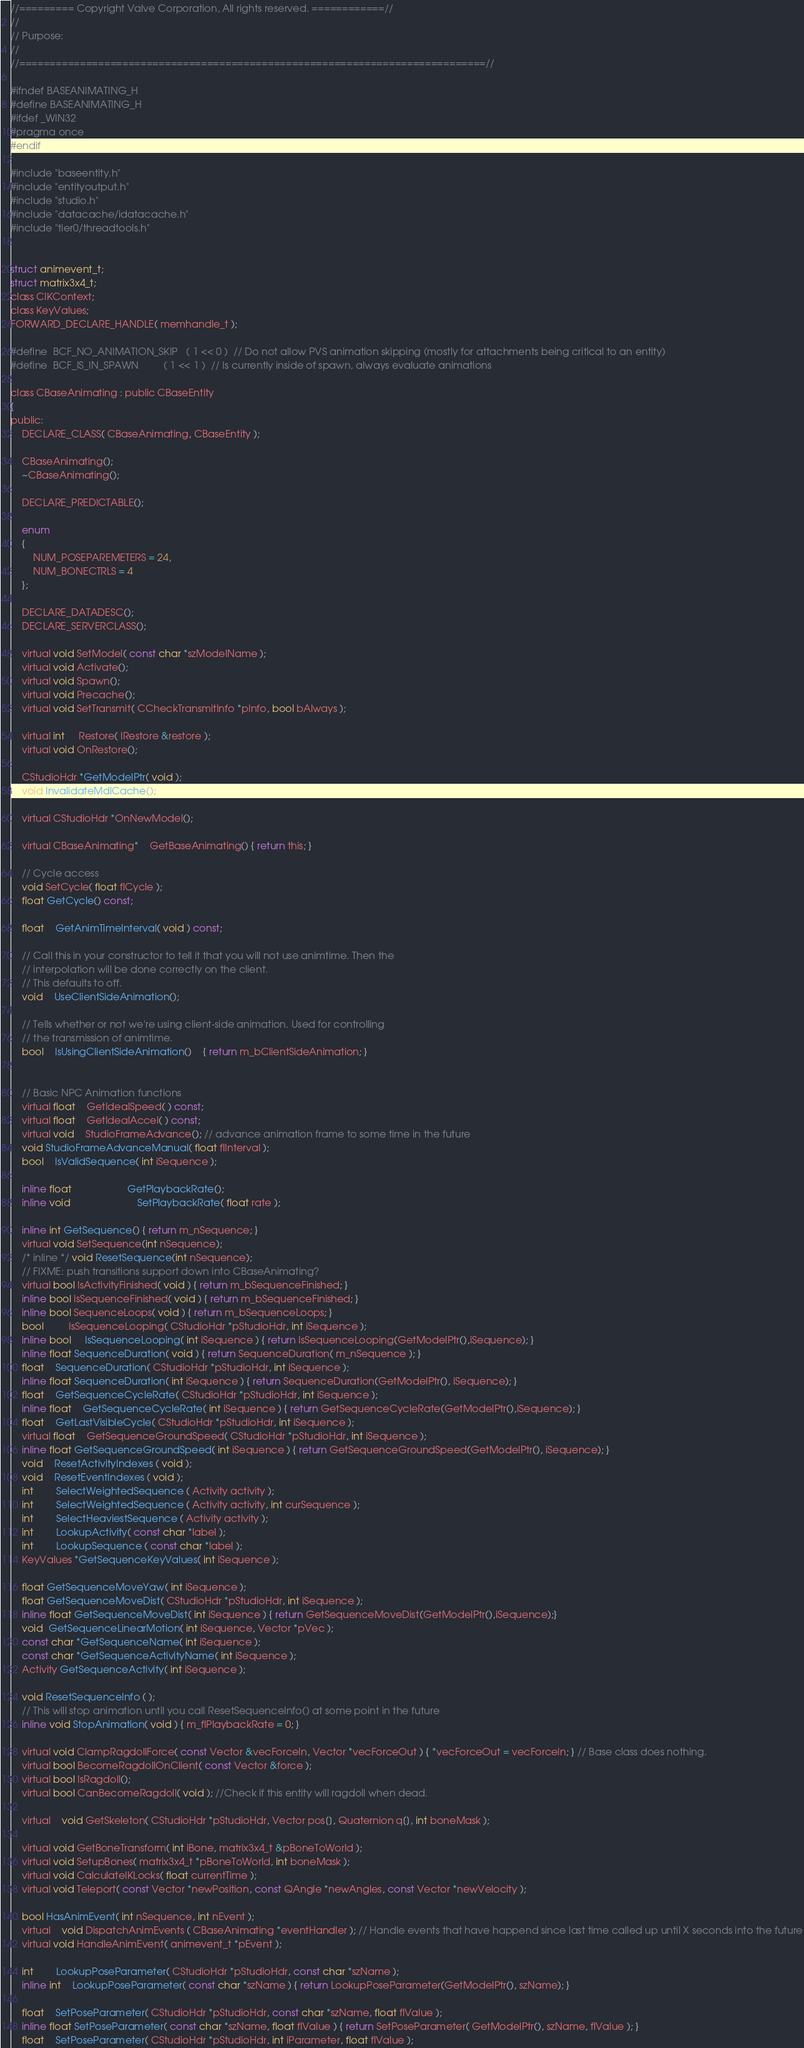<code> <loc_0><loc_0><loc_500><loc_500><_C_>//========= Copyright Valve Corporation, All rights reserved. ============//
//
// Purpose: 
//
//=============================================================================//

#ifndef BASEANIMATING_H
#define BASEANIMATING_H
#ifdef _WIN32
#pragma once
#endif

#include "baseentity.h"
#include "entityoutput.h"
#include "studio.h"
#include "datacache/idatacache.h"
#include "tier0/threadtools.h"


struct animevent_t;
struct matrix3x4_t;
class CIKContext;
class KeyValues;
FORWARD_DECLARE_HANDLE( memhandle_t );

#define	BCF_NO_ANIMATION_SKIP	( 1 << 0 )	// Do not allow PVS animation skipping (mostly for attachments being critical to an entity)
#define	BCF_IS_IN_SPAWN			( 1 << 1 )	// Is currently inside of spawn, always evaluate animations

class CBaseAnimating : public CBaseEntity
{
public:
	DECLARE_CLASS( CBaseAnimating, CBaseEntity );

	CBaseAnimating();
	~CBaseAnimating();

	DECLARE_PREDICTABLE();

	enum
	{
		NUM_POSEPAREMETERS = 24,
		NUM_BONECTRLS = 4
	};

	DECLARE_DATADESC();
	DECLARE_SERVERCLASS();

	virtual void SetModel( const char *szModelName );
	virtual void Activate();
	virtual void Spawn();
	virtual void Precache();
	virtual void SetTransmit( CCheckTransmitInfo *pInfo, bool bAlways );

	virtual int	 Restore( IRestore &restore );
	virtual void OnRestore();

	CStudioHdr *GetModelPtr( void );
	void InvalidateMdlCache();

	virtual CStudioHdr *OnNewModel();

	virtual CBaseAnimating*	GetBaseAnimating() { return this; }

	// Cycle access
	void SetCycle( float flCycle );
	float GetCycle() const;

	float	GetAnimTimeInterval( void ) const;

	// Call this in your constructor to tell it that you will not use animtime. Then the
	// interpolation will be done correctly on the client.
	// This defaults to off.
	void	UseClientSideAnimation();

	// Tells whether or not we're using client-side animation. Used for controlling
	// the transmission of animtime.
	bool	IsUsingClientSideAnimation()	{ return m_bClientSideAnimation; }


	// Basic NPC Animation functions
	virtual float	GetIdealSpeed( ) const;
	virtual float	GetIdealAccel( ) const;
	virtual void	StudioFrameAdvance(); // advance animation frame to some time in the future
	void StudioFrameAdvanceManual( float flInterval );
	bool	IsValidSequence( int iSequence );

	inline float					GetPlaybackRate();
	inline void						SetPlaybackRate( float rate );

	inline int GetSequence() { return m_nSequence; }
	virtual void SetSequence(int nSequence);
	/* inline */ void ResetSequence(int nSequence);
	// FIXME: push transitions support down into CBaseAnimating?
	virtual bool IsActivityFinished( void ) { return m_bSequenceFinished; }
	inline bool IsSequenceFinished( void ) { return m_bSequenceFinished; }
	inline bool SequenceLoops( void ) { return m_bSequenceLoops; }
	bool		 IsSequenceLooping( CStudioHdr *pStudioHdr, int iSequence );
	inline bool	 IsSequenceLooping( int iSequence ) { return IsSequenceLooping(GetModelPtr(),iSequence); }
	inline float SequenceDuration( void ) { return SequenceDuration( m_nSequence ); }
	float	SequenceDuration( CStudioHdr *pStudioHdr, int iSequence );
	inline float SequenceDuration( int iSequence ) { return SequenceDuration(GetModelPtr(), iSequence); }
	float	GetSequenceCycleRate( CStudioHdr *pStudioHdr, int iSequence );
	inline float	GetSequenceCycleRate( int iSequence ) { return GetSequenceCycleRate(GetModelPtr(),iSequence); }
	float	GetLastVisibleCycle( CStudioHdr *pStudioHdr, int iSequence );
	virtual float	GetSequenceGroundSpeed( CStudioHdr *pStudioHdr, int iSequence );
	inline float GetSequenceGroundSpeed( int iSequence ) { return GetSequenceGroundSpeed(GetModelPtr(), iSequence); }
	void	ResetActivityIndexes ( void );
	void    ResetEventIndexes ( void );
	int		SelectWeightedSequence ( Activity activity );
	int		SelectWeightedSequence ( Activity activity, int curSequence );
	int		SelectHeaviestSequence ( Activity activity );
	int		LookupActivity( const char *label );
	int		LookupSequence ( const char *label );
	KeyValues *GetSequenceKeyValues( int iSequence );

	float GetSequenceMoveYaw( int iSequence );
	float GetSequenceMoveDist( CStudioHdr *pStudioHdr, int iSequence );
	inline float GetSequenceMoveDist( int iSequence ) { return GetSequenceMoveDist(GetModelPtr(),iSequence);}
	void  GetSequenceLinearMotion( int iSequence, Vector *pVec );
	const char *GetSequenceName( int iSequence );
	const char *GetSequenceActivityName( int iSequence );
	Activity GetSequenceActivity( int iSequence );

	void ResetSequenceInfo ( );
	// This will stop animation until you call ResetSequenceInfo() at some point in the future
	inline void StopAnimation( void ) { m_flPlaybackRate = 0; }

	virtual void ClampRagdollForce( const Vector &vecForceIn, Vector *vecForceOut ) { *vecForceOut = vecForceIn; } // Base class does nothing.
	virtual bool BecomeRagdollOnClient( const Vector &force );
	virtual bool IsRagdoll();
	virtual bool CanBecomeRagdoll( void ); //Check if this entity will ragdoll when dead.

	virtual	void GetSkeleton( CStudioHdr *pStudioHdr, Vector pos[], Quaternion q[], int boneMask );

	virtual void GetBoneTransform( int iBone, matrix3x4_t &pBoneToWorld );
	virtual void SetupBones( matrix3x4_t *pBoneToWorld, int boneMask );
	virtual void CalculateIKLocks( float currentTime );
	virtual void Teleport( const Vector *newPosition, const QAngle *newAngles, const Vector *newVelocity );

	bool HasAnimEvent( int nSequence, int nEvent );
	virtual	void DispatchAnimEvents ( CBaseAnimating *eventHandler ); // Handle events that have happend since last time called up until X seconds into the future
	virtual void HandleAnimEvent( animevent_t *pEvent );

	int		LookupPoseParameter( CStudioHdr *pStudioHdr, const char *szName );
	inline int	LookupPoseParameter( const char *szName ) { return LookupPoseParameter(GetModelPtr(), szName); }

	float	SetPoseParameter( CStudioHdr *pStudioHdr, const char *szName, float flValue );
	inline float SetPoseParameter( const char *szName, float flValue ) { return SetPoseParameter( GetModelPtr(), szName, flValue ); }
	float	SetPoseParameter( CStudioHdr *pStudioHdr, int iParameter, float flValue );</code> 